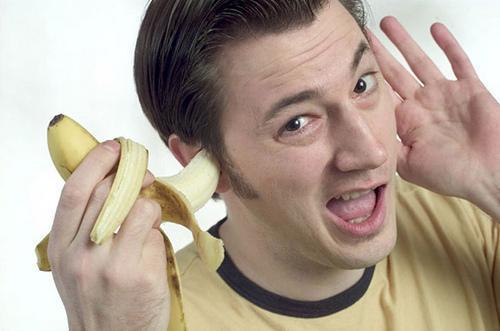How many bananas are in his hands?
Give a very brief answer. 1. 